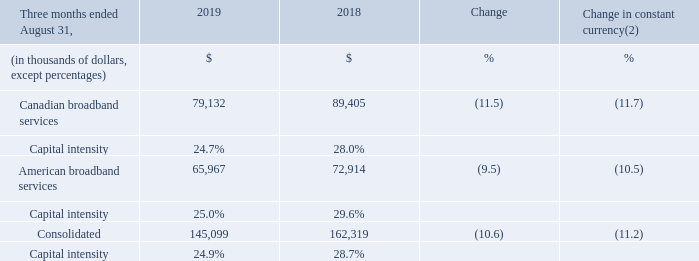ACQUISITIONS OF PROPERTY, PLANT AND EQUIPMENT
The acquisitions of property, plant and equipment as well as the capital intensity per operating segment are as follows:
(1) Fiscal 2018 was restated to comply with IFRS 15 and to reflect a change in accounting policy. For further details, please consult the "Accounting policies" section. (2) Fiscal 2019 actuals are translated at the average foreign exchange rate of the comparable period of fiscal 2018 which was 1.3100 USD/CDN.
Fiscal 2019 fourth-quarter acquisitions of property, plant and equipment decreased by 10.6% (11.2% in constant currency) mainly due to lower capital expenditures in the Canadian and American broadband services segments. Fiscal 2019 fourth-quarter capital intensity reached 24.9% compared to 28.7% for the same period of the prior year mainly as a result of lower capital capital expenditures combined with higher revenue.
What is the rate at which Fiscal 2019 actuals are translated at the average foreign exchange rate of the comparable period of fiscal 2018? 1.3100 usd/cdn. Why did the Fiscal 2019 fourth-quarter acquisitions of property, plant and equipment decreased? Lower capital expenditures in the canadian and american broadband services segments. What led to Fiscal 2019 fourth-quarter capital intensity reach 24.9%? Lower capital capital expenditures combined with higher revenue. What is the increase/ (decrease) Canadian broadband services from 2018 to 2019?
Answer scale should be: thousand. 79,132-89,405
Answer: -10273. What is the increase/ (decrease) American broadband services from 2018 to 2019?
Answer scale should be: thousand. 65,967-72,914
Answer: -6947. What is the increase/ (decrease) Consolidated from 2018 to 2019?
Answer scale should be: thousand. 145,099-162,319
Answer: -17220. 